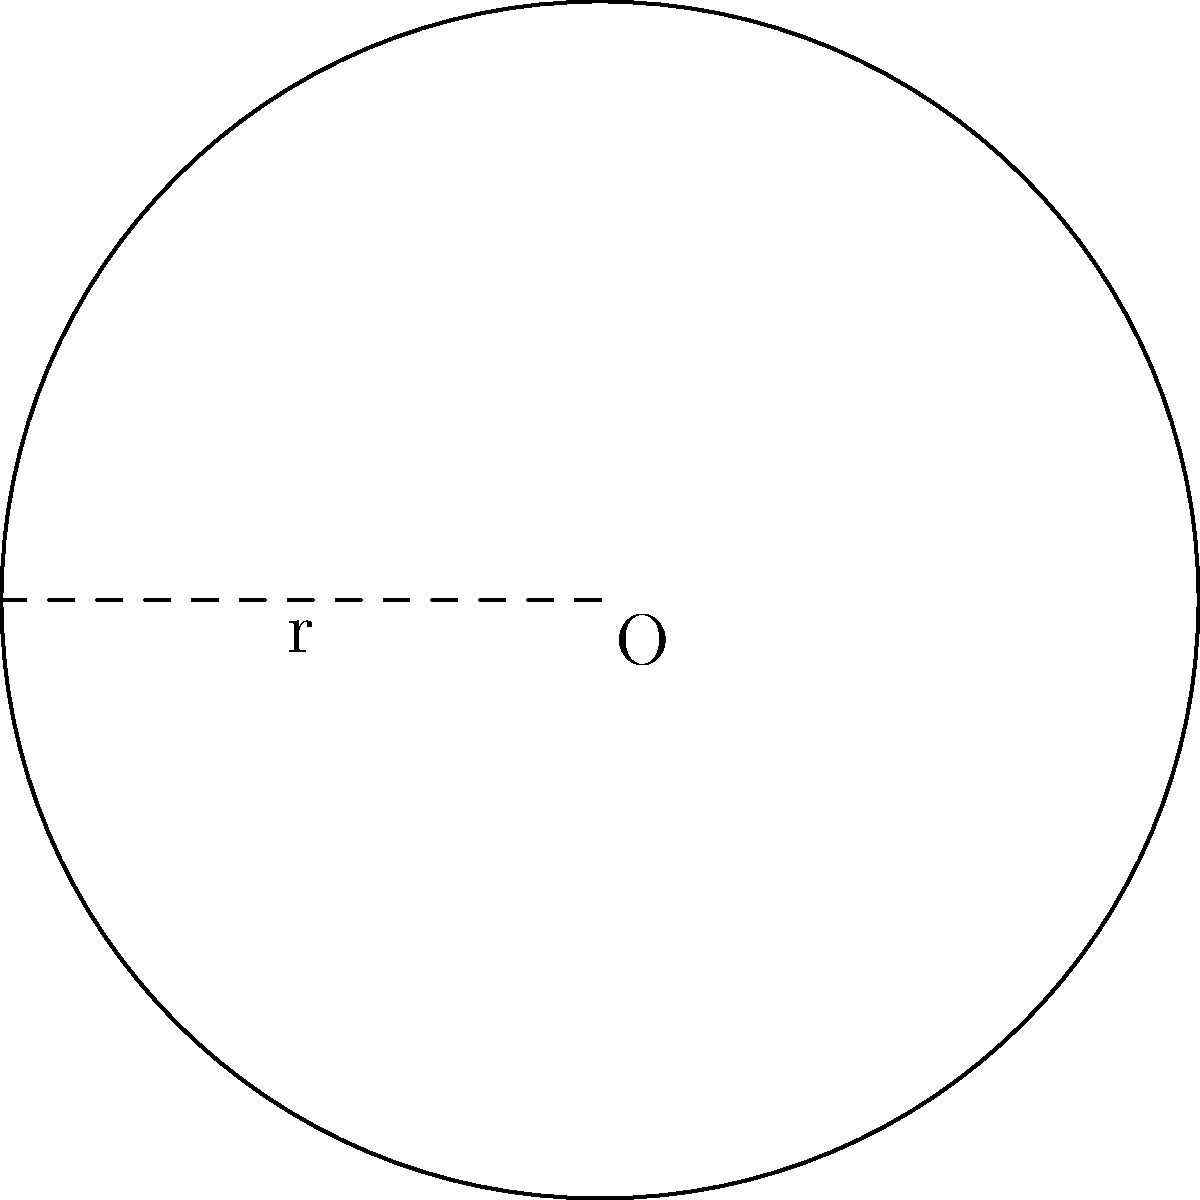In your favorite retro sports game, the circular playing field has a radius of 30 units. What is the area of this classic gaming arena? To find the area of a circular field, we'll use the formula for the area of a circle:

$$A = \pi r^2$$

Where:
$A$ = area of the circle
$\pi$ = pi (approximately 3.14159)
$r$ = radius of the circle

Given:
Radius ($r$) = 30 units

Let's substitute these values into the formula:

$$A = \pi (30)^2$$
$$A = \pi (900)$$
$$A = 2827.43 \text{ square units}$$

Rounding to the nearest whole number:
$$A \approx 2827 \text{ square units}$$

This result gives us the total area of the circular playing field in our retro sports game.
Answer: 2827 square units 